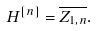Convert formula to latex. <formula><loc_0><loc_0><loc_500><loc_500>H ^ { [ n ] } = \overline { Z _ { 1 , n } } .</formula> 